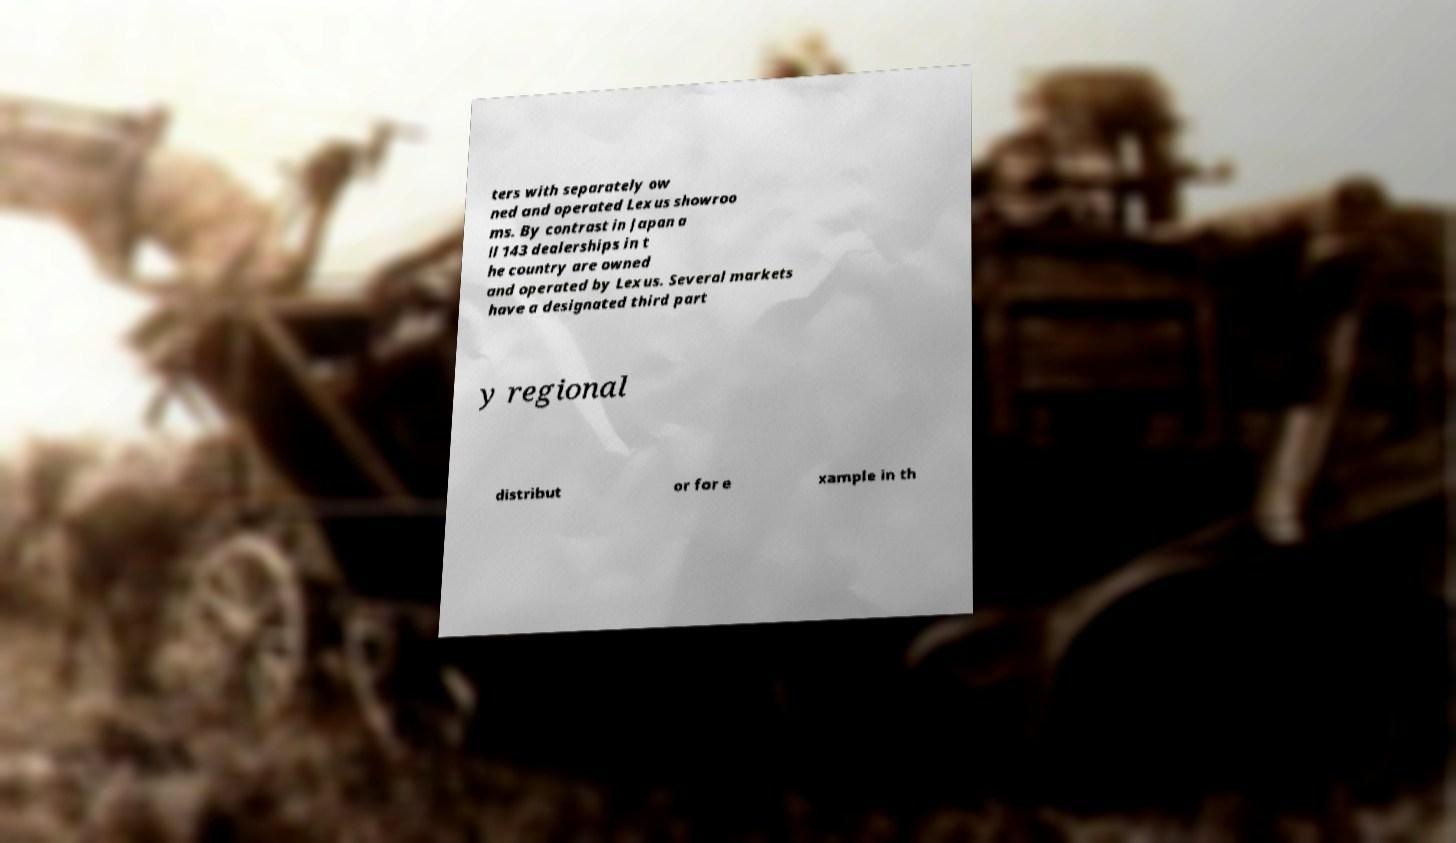Please identify and transcribe the text found in this image. ters with separately ow ned and operated Lexus showroo ms. By contrast in Japan a ll 143 dealerships in t he country are owned and operated by Lexus. Several markets have a designated third part y regional distribut or for e xample in th 